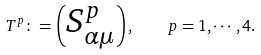<formula> <loc_0><loc_0><loc_500><loc_500>T ^ { p } \colon = \begin{pmatrix} S ^ { p } _ { \alpha \mu } \end{pmatrix} , \quad p = 1 , \cdots , 4 .</formula> 